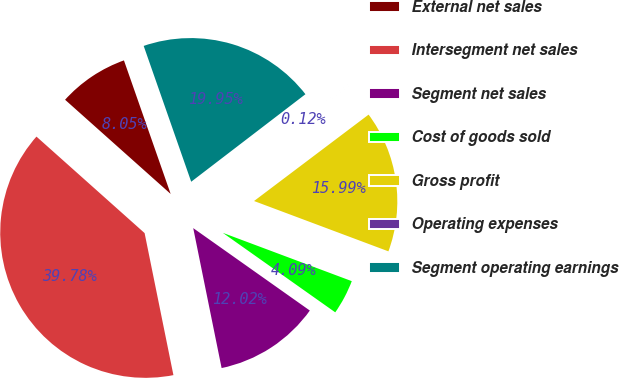<chart> <loc_0><loc_0><loc_500><loc_500><pie_chart><fcel>External net sales<fcel>Intersegment net sales<fcel>Segment net sales<fcel>Cost of goods sold<fcel>Gross profit<fcel>Operating expenses<fcel>Segment operating earnings<nl><fcel>8.05%<fcel>39.78%<fcel>12.02%<fcel>4.09%<fcel>15.99%<fcel>0.12%<fcel>19.95%<nl></chart> 